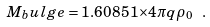<formula> <loc_0><loc_0><loc_500><loc_500>M _ { b } u l g e = 1 . 6 0 8 5 1 { \times } 4 \pi q \rho _ { 0 } \ .</formula> 